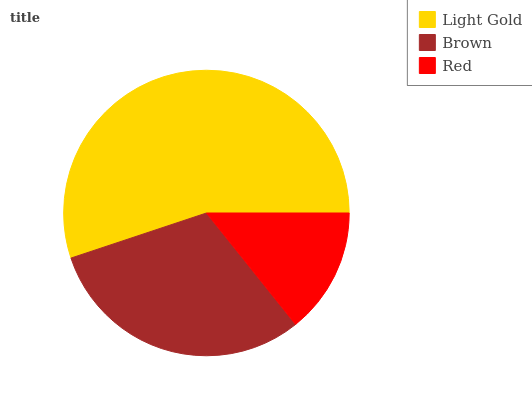Is Red the minimum?
Answer yes or no. Yes. Is Light Gold the maximum?
Answer yes or no. Yes. Is Brown the minimum?
Answer yes or no. No. Is Brown the maximum?
Answer yes or no. No. Is Light Gold greater than Brown?
Answer yes or no. Yes. Is Brown less than Light Gold?
Answer yes or no. Yes. Is Brown greater than Light Gold?
Answer yes or no. No. Is Light Gold less than Brown?
Answer yes or no. No. Is Brown the high median?
Answer yes or no. Yes. Is Brown the low median?
Answer yes or no. Yes. Is Light Gold the high median?
Answer yes or no. No. Is Light Gold the low median?
Answer yes or no. No. 